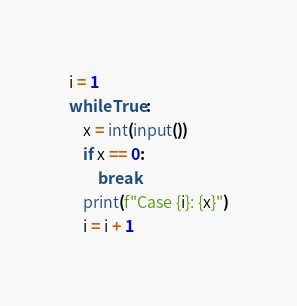Convert code to text. <code><loc_0><loc_0><loc_500><loc_500><_Python_>i = 1
while True:
    x = int(input())
    if x == 0:
        break
    print(f"Case {i}: {x}")
    i = i + 1
</code> 